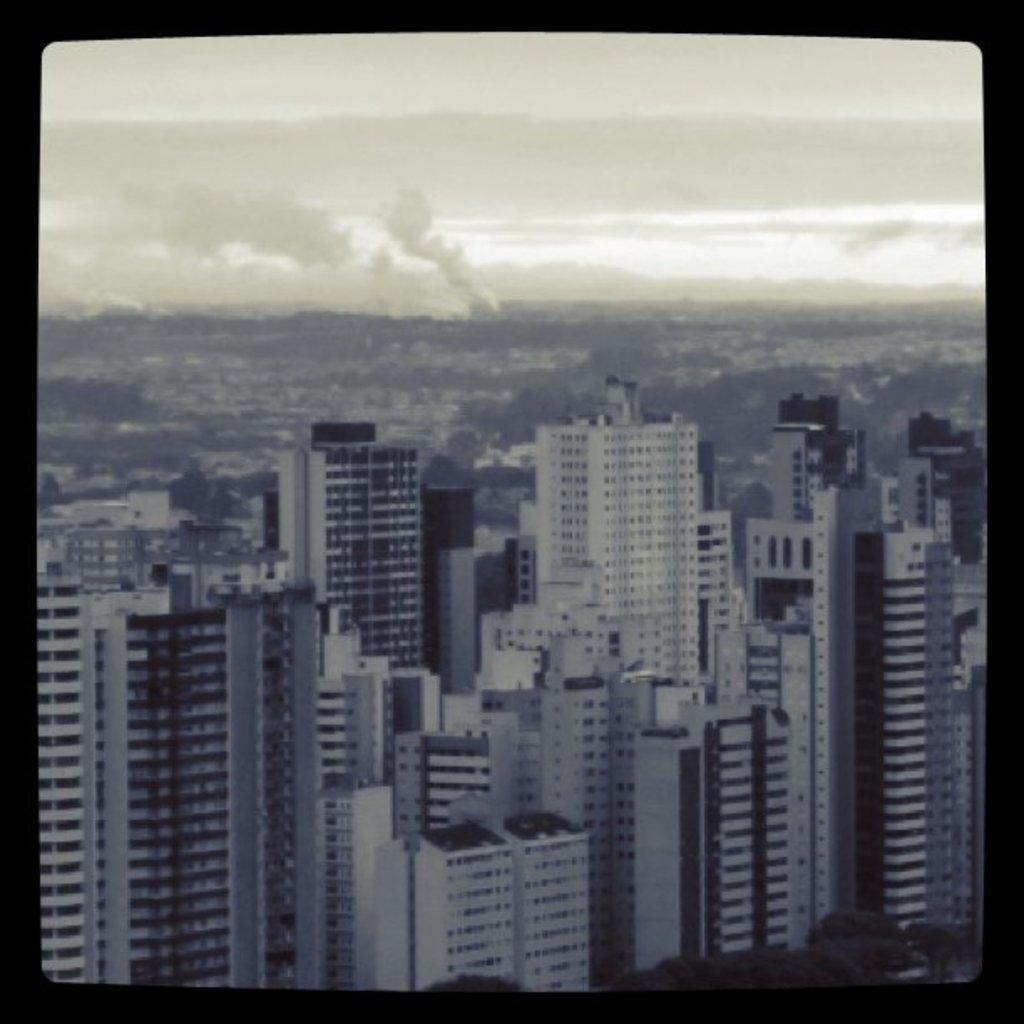In one or two sentences, can you explain what this image depicts? In this picture we can see many tall buildings in the front. On the top there is a sky. 